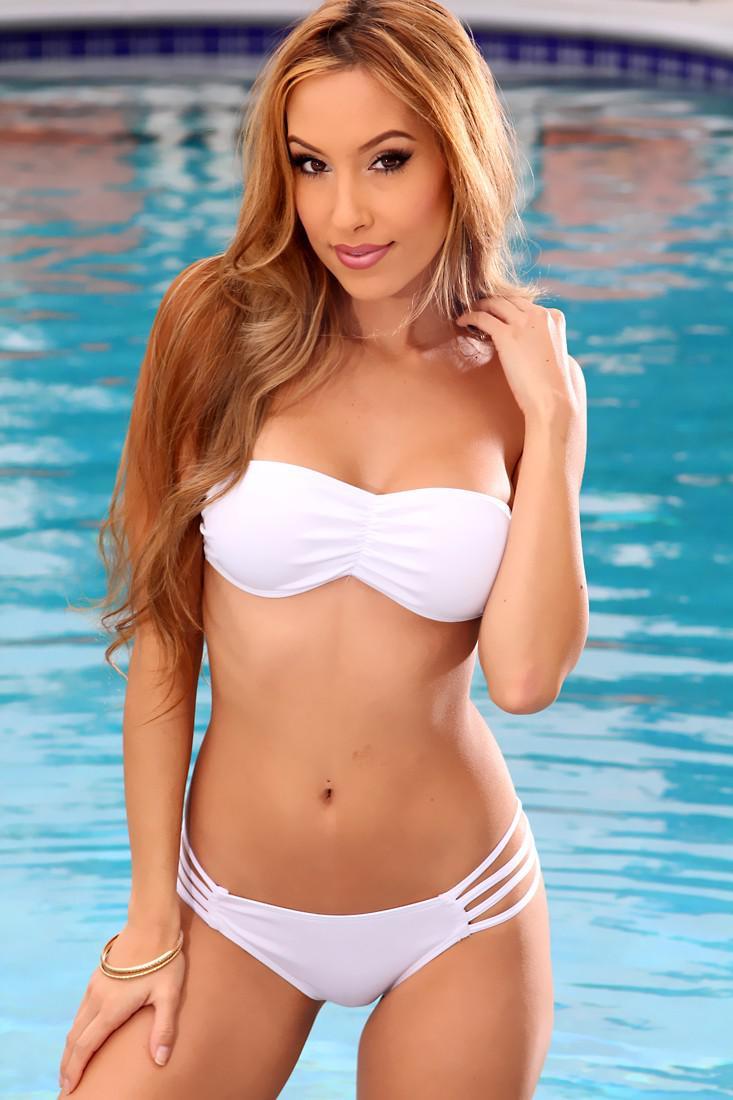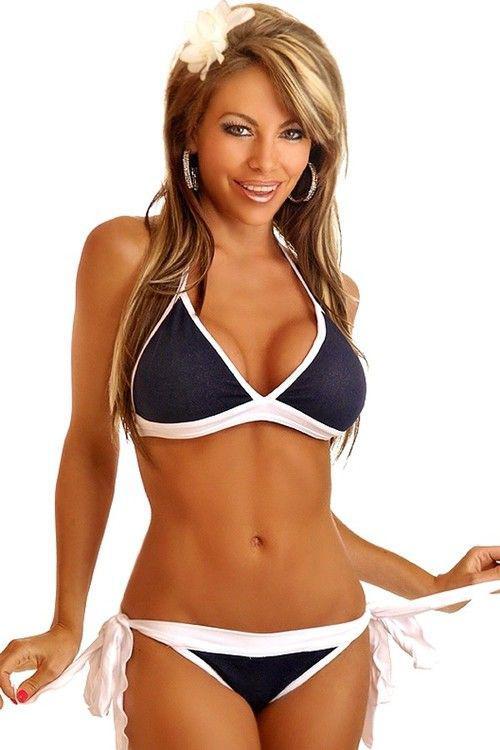The first image is the image on the left, the second image is the image on the right. For the images shown, is this caption "All bikinis shown are solid black." true? Answer yes or no. No. The first image is the image on the left, the second image is the image on the right. Considering the images on both sides, is "One of the images shows a woman near a swimming pool." valid? Answer yes or no. Yes. 